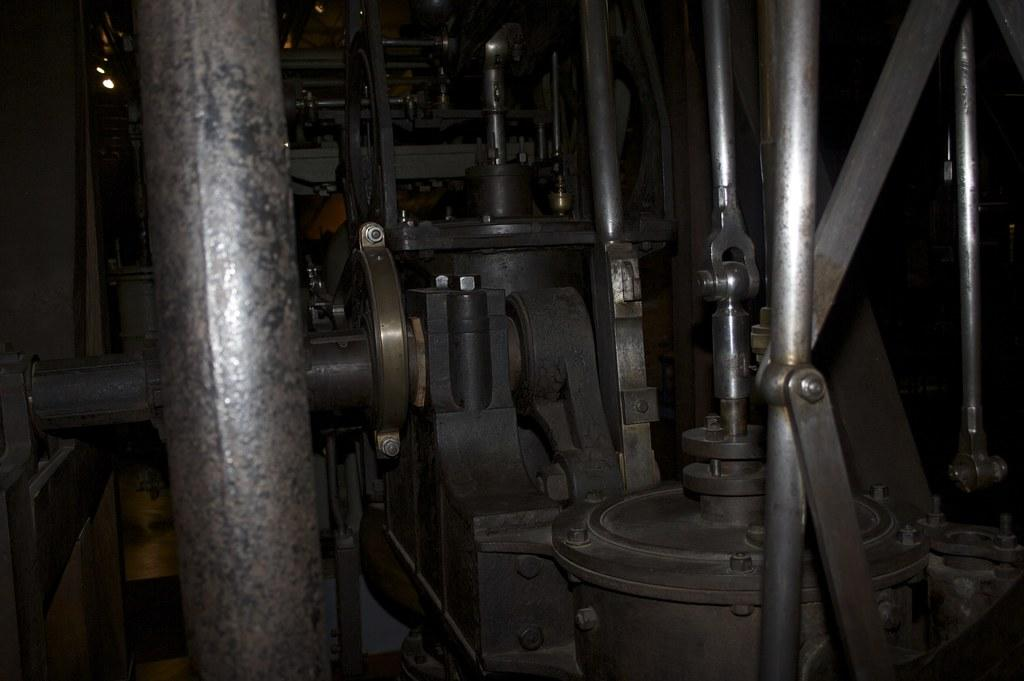What objects can be seen in the image? There are rods and lights in the image. Can you describe the unspecified objects in the image? Unfortunately, the provided facts do not specify the nature of the unspecified objects. What is the color of the background in the image? The background of the image is dark. What type of territory is being claimed by the team in the image? There is no territory, team, or claim being depicted in the image. The image only features rods, lights, and unspecified objects against a dark background. 